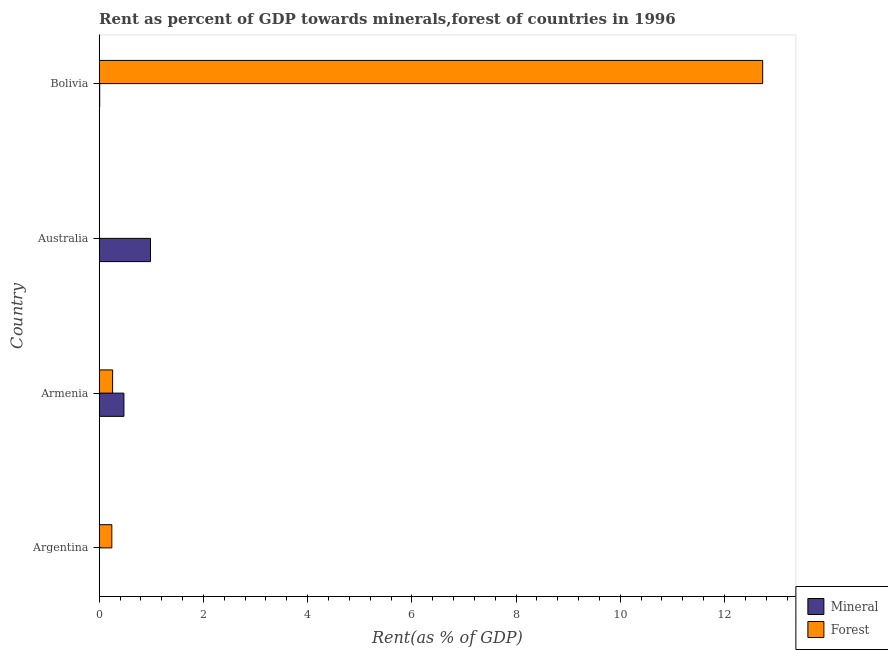How many groups of bars are there?
Provide a succinct answer. 4. Are the number of bars per tick equal to the number of legend labels?
Give a very brief answer. Yes. How many bars are there on the 3rd tick from the top?
Keep it short and to the point. 2. What is the forest rent in Armenia?
Your answer should be compact. 0.26. Across all countries, what is the maximum mineral rent?
Ensure brevity in your answer.  0.98. Across all countries, what is the minimum mineral rent?
Provide a short and direct response. 0. In which country was the forest rent maximum?
Provide a short and direct response. Bolivia. What is the total forest rent in the graph?
Ensure brevity in your answer.  13.23. What is the difference between the forest rent in Armenia and that in Australia?
Offer a very short reply. 0.26. What is the difference between the forest rent in Argentina and the mineral rent in Bolivia?
Your response must be concise. 0.23. What is the average forest rent per country?
Your answer should be compact. 3.31. What is the difference between the forest rent and mineral rent in Armenia?
Provide a succinct answer. -0.22. What is the ratio of the mineral rent in Argentina to that in Armenia?
Keep it short and to the point. 0. Is the mineral rent in Argentina less than that in Armenia?
Your answer should be very brief. Yes. What is the difference between the highest and the second highest forest rent?
Provide a succinct answer. 12.47. What is the difference between the highest and the lowest forest rent?
Provide a succinct answer. 12.73. What does the 1st bar from the top in Armenia represents?
Provide a succinct answer. Forest. What does the 1st bar from the bottom in Argentina represents?
Keep it short and to the point. Mineral. Are all the bars in the graph horizontal?
Keep it short and to the point. Yes. How many countries are there in the graph?
Your response must be concise. 4. Does the graph contain grids?
Your response must be concise. No. Where does the legend appear in the graph?
Provide a succinct answer. Bottom right. How are the legend labels stacked?
Make the answer very short. Vertical. What is the title of the graph?
Keep it short and to the point. Rent as percent of GDP towards minerals,forest of countries in 1996. Does "International Visitors" appear as one of the legend labels in the graph?
Offer a terse response. No. What is the label or title of the X-axis?
Give a very brief answer. Rent(as % of GDP). What is the Rent(as % of GDP) of Mineral in Argentina?
Give a very brief answer. 0. What is the Rent(as % of GDP) in Forest in Argentina?
Your answer should be very brief. 0.24. What is the Rent(as % of GDP) in Mineral in Armenia?
Provide a short and direct response. 0.47. What is the Rent(as % of GDP) of Forest in Armenia?
Ensure brevity in your answer.  0.26. What is the Rent(as % of GDP) in Mineral in Australia?
Give a very brief answer. 0.98. What is the Rent(as % of GDP) of Forest in Australia?
Give a very brief answer. 0. What is the Rent(as % of GDP) in Mineral in Bolivia?
Your response must be concise. 0.01. What is the Rent(as % of GDP) in Forest in Bolivia?
Your answer should be very brief. 12.73. Across all countries, what is the maximum Rent(as % of GDP) of Mineral?
Your answer should be very brief. 0.98. Across all countries, what is the maximum Rent(as % of GDP) of Forest?
Your answer should be compact. 12.73. Across all countries, what is the minimum Rent(as % of GDP) of Mineral?
Your response must be concise. 0. Across all countries, what is the minimum Rent(as % of GDP) of Forest?
Provide a succinct answer. 0. What is the total Rent(as % of GDP) of Mineral in the graph?
Your answer should be very brief. 1.47. What is the total Rent(as % of GDP) in Forest in the graph?
Your response must be concise. 13.23. What is the difference between the Rent(as % of GDP) in Mineral in Argentina and that in Armenia?
Provide a succinct answer. -0.47. What is the difference between the Rent(as % of GDP) of Forest in Argentina and that in Armenia?
Your answer should be compact. -0.02. What is the difference between the Rent(as % of GDP) of Mineral in Argentina and that in Australia?
Provide a short and direct response. -0.98. What is the difference between the Rent(as % of GDP) of Forest in Argentina and that in Australia?
Your answer should be very brief. 0.24. What is the difference between the Rent(as % of GDP) of Mineral in Argentina and that in Bolivia?
Keep it short and to the point. -0.01. What is the difference between the Rent(as % of GDP) in Forest in Argentina and that in Bolivia?
Offer a terse response. -12.49. What is the difference between the Rent(as % of GDP) in Mineral in Armenia and that in Australia?
Keep it short and to the point. -0.51. What is the difference between the Rent(as % of GDP) in Forest in Armenia and that in Australia?
Provide a short and direct response. 0.26. What is the difference between the Rent(as % of GDP) in Mineral in Armenia and that in Bolivia?
Your answer should be very brief. 0.47. What is the difference between the Rent(as % of GDP) of Forest in Armenia and that in Bolivia?
Offer a terse response. -12.48. What is the difference between the Rent(as % of GDP) in Mineral in Australia and that in Bolivia?
Give a very brief answer. 0.97. What is the difference between the Rent(as % of GDP) of Forest in Australia and that in Bolivia?
Give a very brief answer. -12.73. What is the difference between the Rent(as % of GDP) of Mineral in Argentina and the Rent(as % of GDP) of Forest in Armenia?
Your response must be concise. -0.26. What is the difference between the Rent(as % of GDP) of Mineral in Argentina and the Rent(as % of GDP) of Forest in Australia?
Keep it short and to the point. 0. What is the difference between the Rent(as % of GDP) in Mineral in Argentina and the Rent(as % of GDP) in Forest in Bolivia?
Provide a short and direct response. -12.73. What is the difference between the Rent(as % of GDP) in Mineral in Armenia and the Rent(as % of GDP) in Forest in Australia?
Give a very brief answer. 0.47. What is the difference between the Rent(as % of GDP) in Mineral in Armenia and the Rent(as % of GDP) in Forest in Bolivia?
Offer a terse response. -12.26. What is the difference between the Rent(as % of GDP) of Mineral in Australia and the Rent(as % of GDP) of Forest in Bolivia?
Provide a short and direct response. -11.75. What is the average Rent(as % of GDP) in Mineral per country?
Your answer should be compact. 0.37. What is the average Rent(as % of GDP) of Forest per country?
Your answer should be very brief. 3.31. What is the difference between the Rent(as % of GDP) of Mineral and Rent(as % of GDP) of Forest in Argentina?
Your response must be concise. -0.24. What is the difference between the Rent(as % of GDP) in Mineral and Rent(as % of GDP) in Forest in Armenia?
Offer a terse response. 0.22. What is the difference between the Rent(as % of GDP) of Mineral and Rent(as % of GDP) of Forest in Australia?
Your answer should be very brief. 0.98. What is the difference between the Rent(as % of GDP) of Mineral and Rent(as % of GDP) of Forest in Bolivia?
Keep it short and to the point. -12.72. What is the ratio of the Rent(as % of GDP) in Mineral in Argentina to that in Armenia?
Ensure brevity in your answer.  0. What is the ratio of the Rent(as % of GDP) of Forest in Argentina to that in Armenia?
Your answer should be very brief. 0.94. What is the ratio of the Rent(as % of GDP) in Mineral in Argentina to that in Australia?
Provide a short and direct response. 0. What is the ratio of the Rent(as % of GDP) in Forest in Argentina to that in Australia?
Your answer should be compact. 150.3. What is the ratio of the Rent(as % of GDP) in Mineral in Argentina to that in Bolivia?
Your answer should be very brief. 0.23. What is the ratio of the Rent(as % of GDP) of Forest in Argentina to that in Bolivia?
Offer a terse response. 0.02. What is the ratio of the Rent(as % of GDP) of Mineral in Armenia to that in Australia?
Provide a succinct answer. 0.48. What is the ratio of the Rent(as % of GDP) of Forest in Armenia to that in Australia?
Offer a very short reply. 159.77. What is the ratio of the Rent(as % of GDP) in Mineral in Armenia to that in Bolivia?
Provide a succinct answer. 51.31. What is the ratio of the Rent(as % of GDP) of Forest in Armenia to that in Bolivia?
Your answer should be very brief. 0.02. What is the ratio of the Rent(as % of GDP) in Mineral in Australia to that in Bolivia?
Provide a succinct answer. 106.48. What is the ratio of the Rent(as % of GDP) in Forest in Australia to that in Bolivia?
Give a very brief answer. 0. What is the difference between the highest and the second highest Rent(as % of GDP) in Mineral?
Your answer should be very brief. 0.51. What is the difference between the highest and the second highest Rent(as % of GDP) in Forest?
Your answer should be very brief. 12.48. What is the difference between the highest and the lowest Rent(as % of GDP) of Mineral?
Provide a succinct answer. 0.98. What is the difference between the highest and the lowest Rent(as % of GDP) in Forest?
Keep it short and to the point. 12.73. 